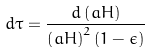Convert formula to latex. <formula><loc_0><loc_0><loc_500><loc_500>d \tau = { \frac { d \left ( a H \right ) } { \left ( a H \right ) ^ { 2 } \left ( 1 - \epsilon \right ) } }</formula> 